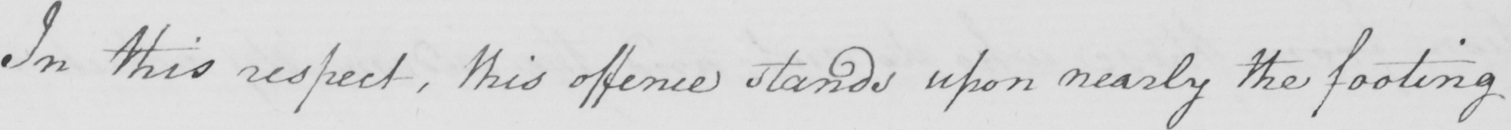Can you read and transcribe this handwriting? In this respect , this offence stands upon nearly the footing 